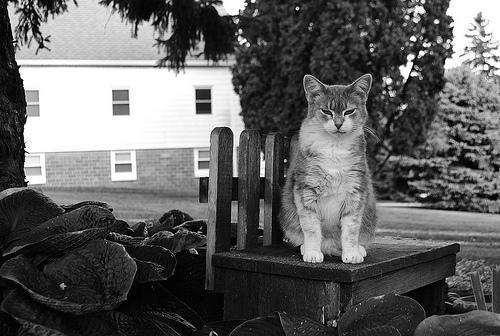How many cats are in the picture?
Give a very brief answer. 1. How many people are petting the cat?
Give a very brief answer. 0. How many ears does the cat have?
Give a very brief answer. 2. How many eyes are on the cat's face?
Give a very brief answer. 2. 